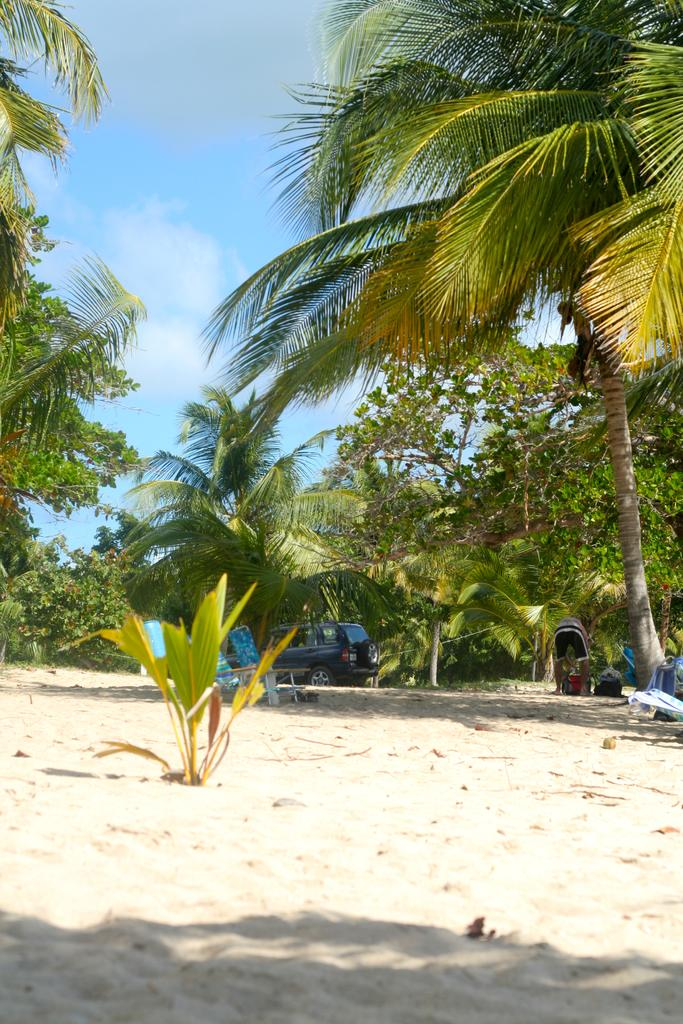What type of vehicle can be seen in the image? There is a vehicle in the image, but the specific type is not mentioned. Where is the vehicle located? The vehicle is on land in the image. What type of vegetation is visible in the image? Plants and trees are visible in the image. What type of ornament is hanging from the trees in the image? There is no mention of any ornaments hanging from the trees in the image. 